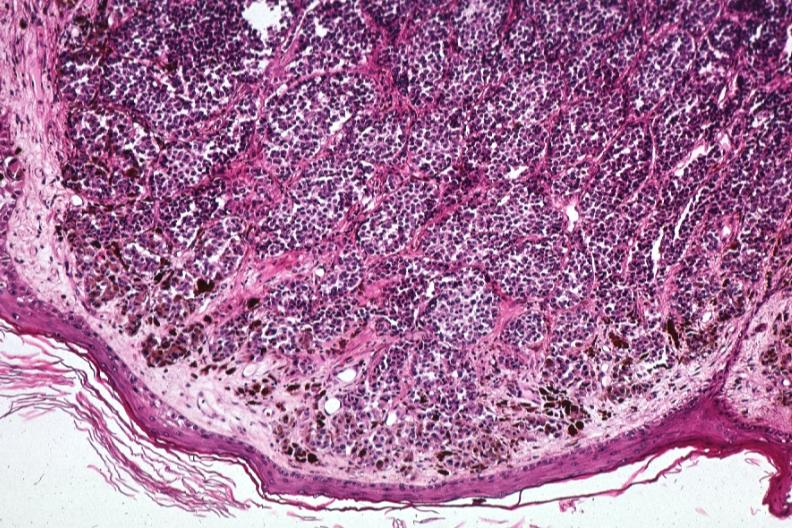what are 1?
Answer the question using a single word or phrase. Same lesion 